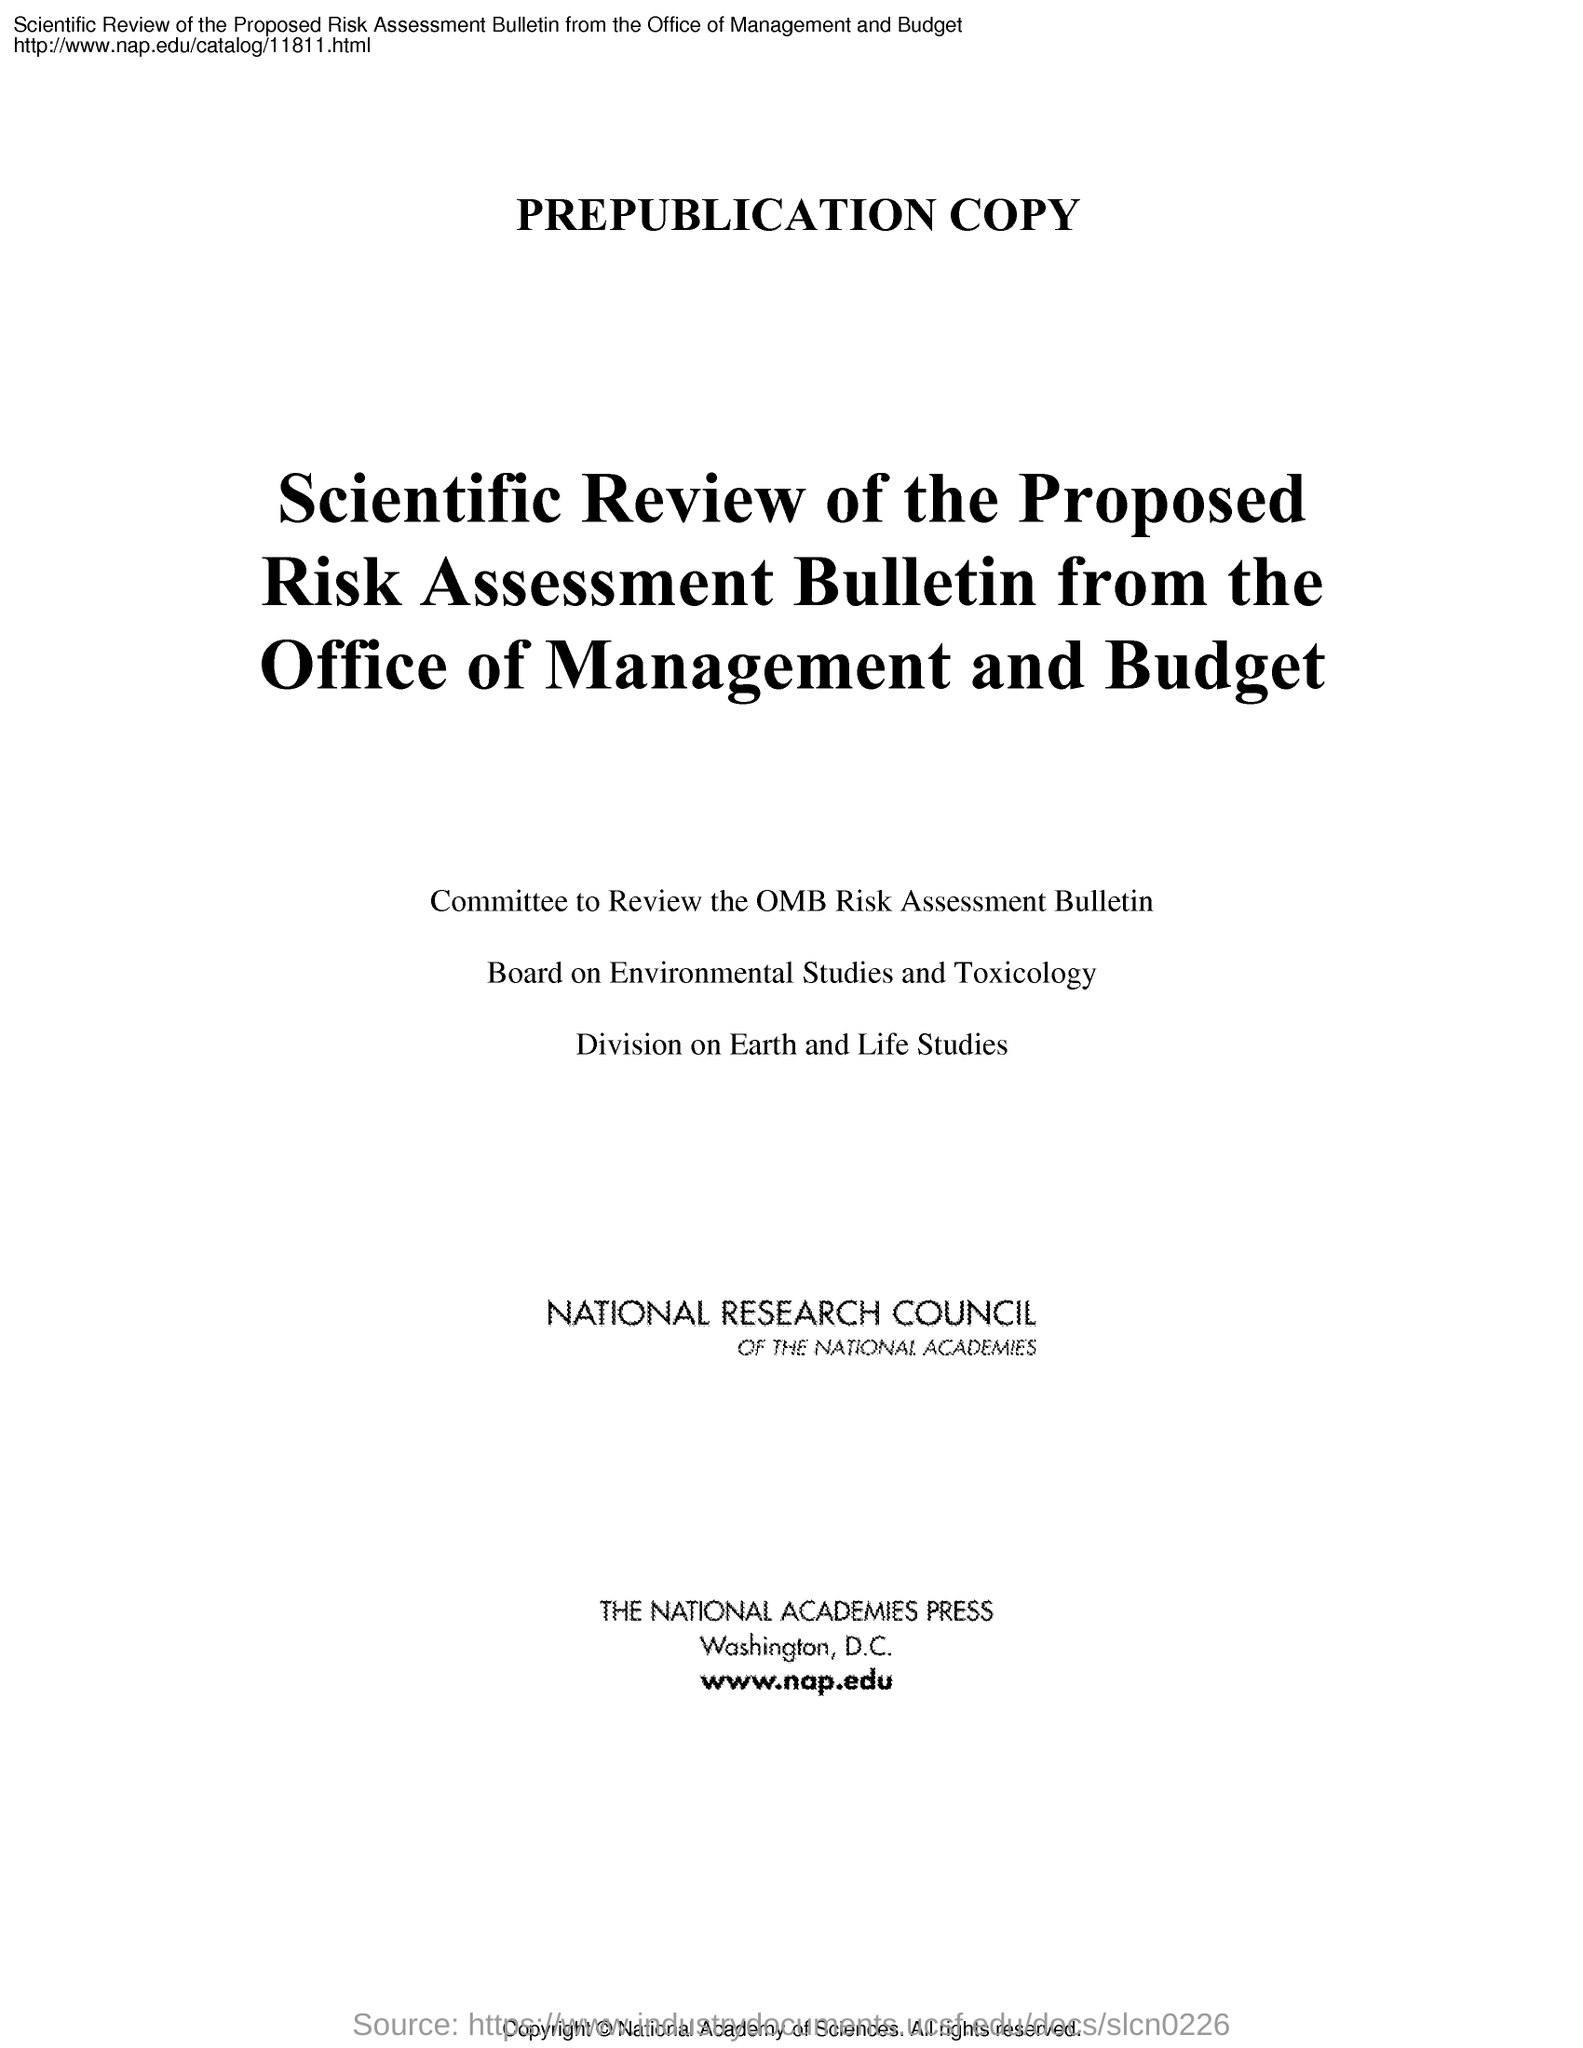What is the main heading of the document?
Ensure brevity in your answer.  Scientific Review of the Proposed Risk Assessment Bulletin from the Office of Management and Budget. Where is The National Academic Press located?
Your response must be concise. Washington, D.C. What is the first heading in the document?
Your response must be concise. Prepublication Copy. 